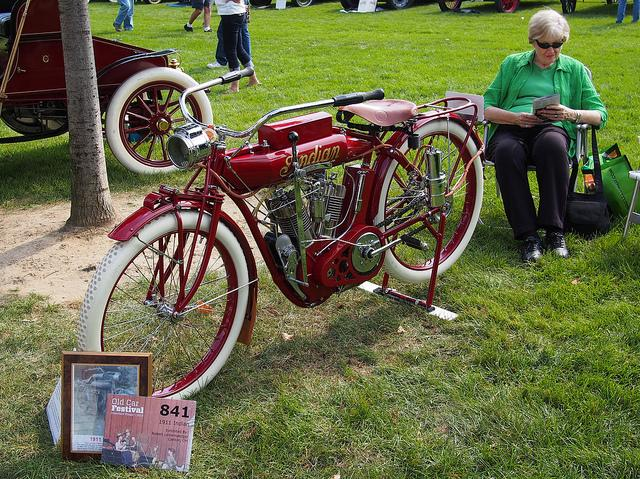For what purpose is this bike being exhibited? Please explain your reasoning. display only. It has the price tag to show that it is to be solved. 